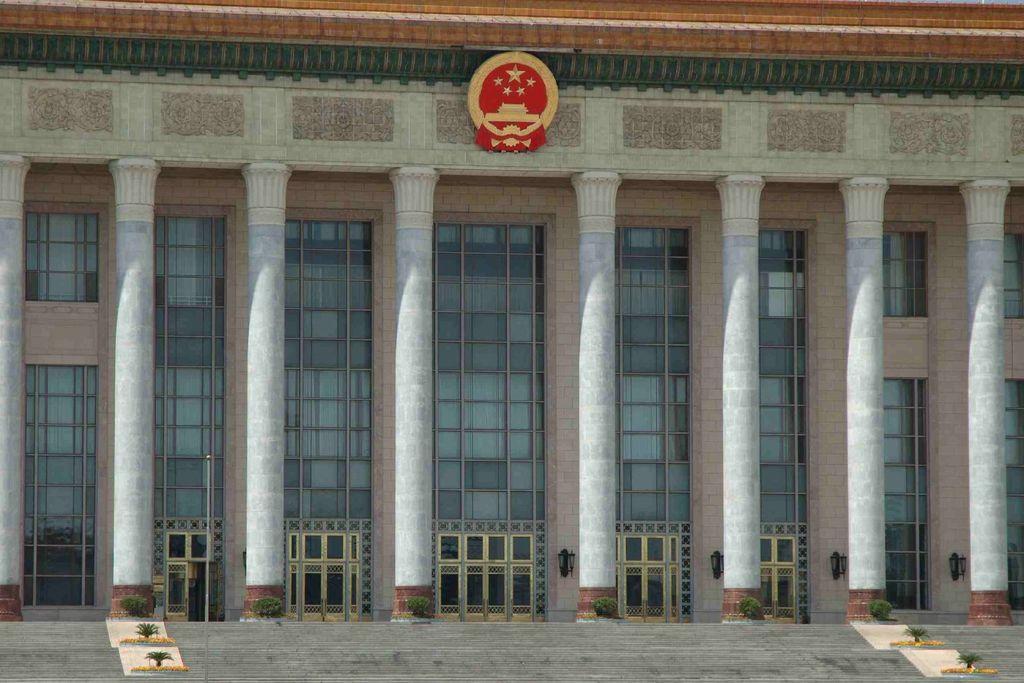Could you give a brief overview of what you see in this image? In the foreground of this image, there are stairs and few plants. In the middle, there are pillars and a building. 